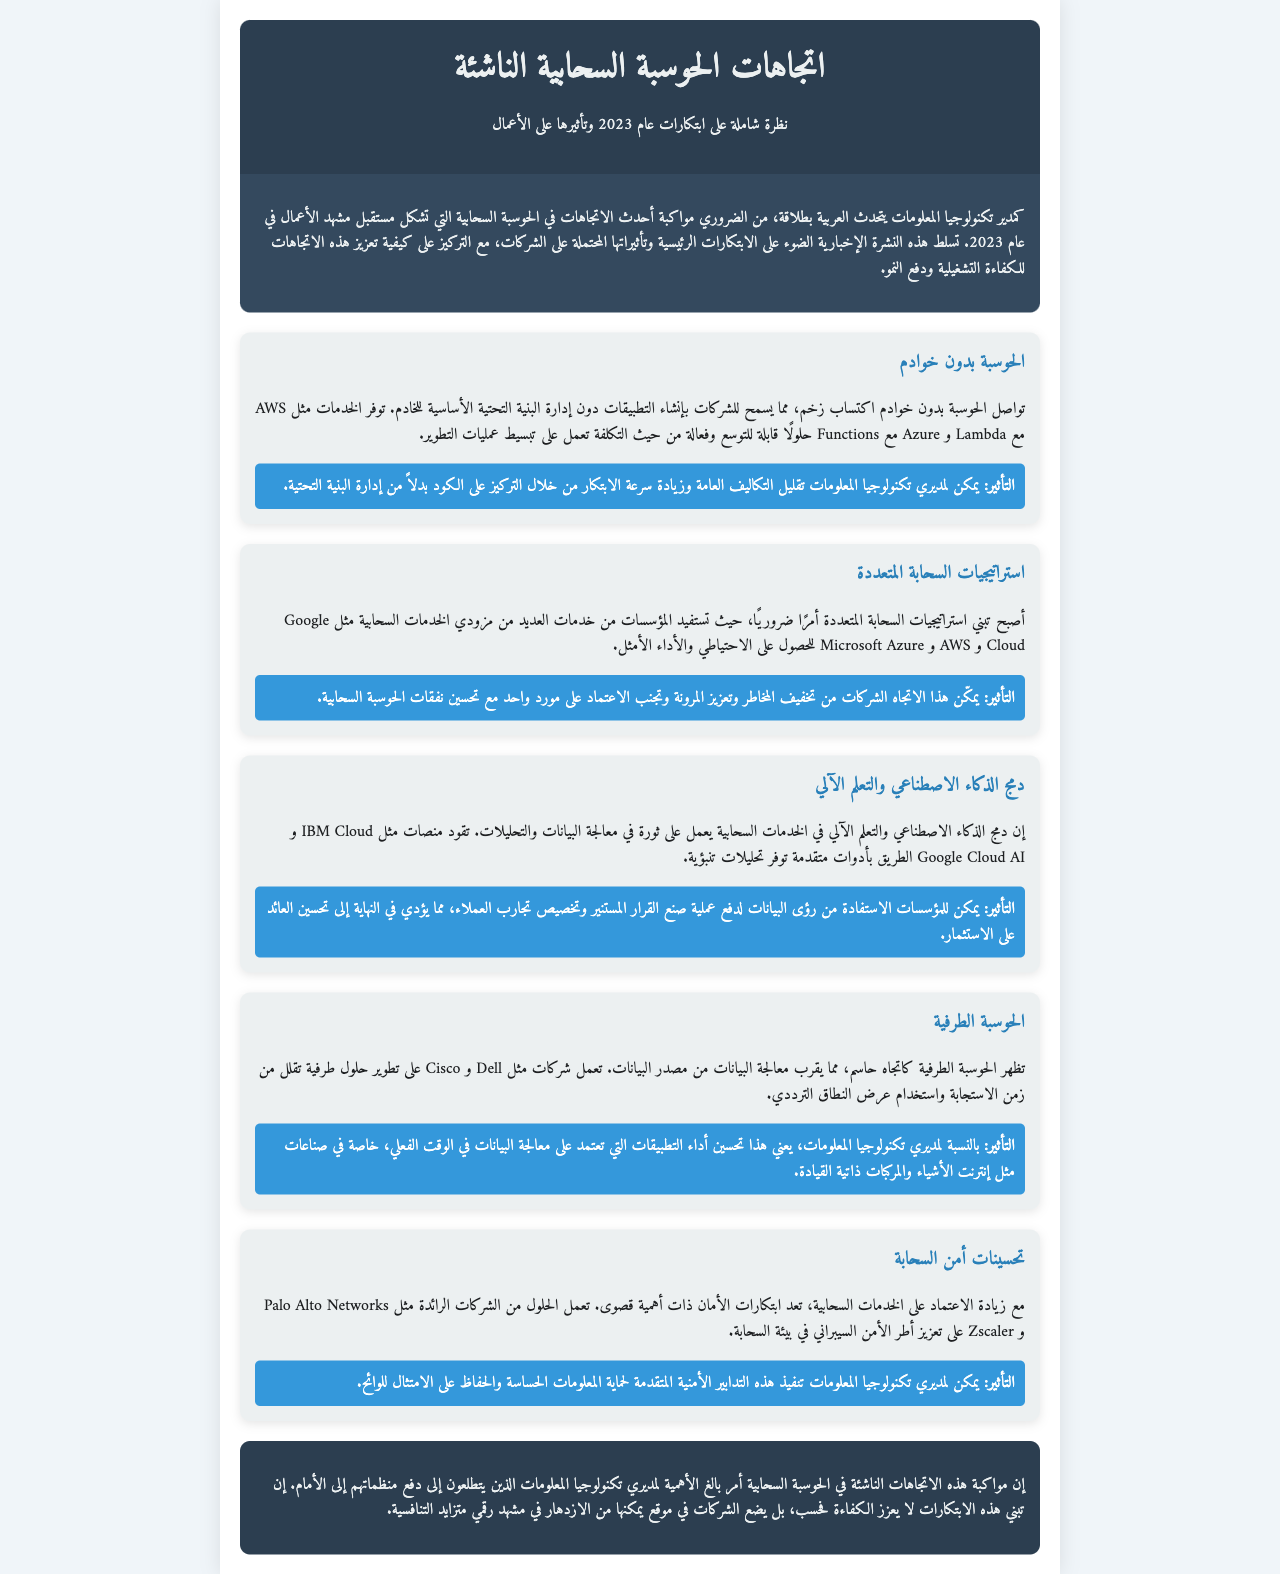ما هو عنوان النشرة الإخبارية؟ عنوان النشرة الإخبارية هو العنوان الرئيسي في رأس الصفحة.
Answer: اتجاهات الحوسبة السحابية الناشئة ما هي الفقرة التعريفية عن النشرة الإخبارية؟ الفقرة التعريفية توضح الهدف من النشرة وأهمية الموضوع.
Answer: كمدير تكنولوجيا المعلومات يتحدث العربية بطلاقة، من الضروري مواكبة أحدث الاتجاهات في الحوسبة السحابية التي تشكل مستقبل مشهد الأعمال في عام 2023 ما هو أحد الاتجاهات الرئيسية المذكورة في النشرة؟ الاتجاهات الرئيسية هي الأقسام المميزة في محتوى النشرة.
Answer: الحوسبة بدون خوادم ما هو التأثير الذي يمكن أن تحدثه الحوسبة بدون خوادم؟ التأثير يوضح الفوائد المترتبة على اعتماد هذه التقنية.
Answer: يمكن لمديري تكنولوجيا المعلومات تقليل التكاليف العامة وزيادة سرعة الابتكار من خلال التركيز على الكود بدلاً من إدارة البنية التحتية ما هي إحدى الشركات التي تقدم حلول الذكاء الاصطناعي والتعلم الآلي؟ الشركات المذكورة في هذا القسم تدل على المبتكرات الرائدة.
Answer: IBM Cloud كيف يمكنك تحسين أداء التطبيقات في الوقت الحقيقي؟ السؤال يتطلب فهم الاتجاة المتعلق بتكنولوجيا المعلومات.
Answer: الحوسبة الطرفية ما أهمية تحسينات أمن السحابة حسب النشرة؟ يوضح هذا السؤال تأثير الأمن على الشركات.
Answer: تعتبر ابتكارات الأمان ذات أهمية قصوى في أي صناعة يمكن أن تكون الحوسبة الطرفية مفيدة بشكل خاص؟ يتطلب هذا السؤال ربط المعلومات الموجودة في قسم الحوسبة الطرفية.
Answer: إنترنت الأشياء والمركبات ذاتية القيادة ما الهدف النهائي من متابعة الاتجاهات الناشئة في الحوسبة السحابية؟ الهدف الرئيسي موجود في الفقرة الختامية من النشرة.
Answer: دفع منظماتهم إلى الأمام 